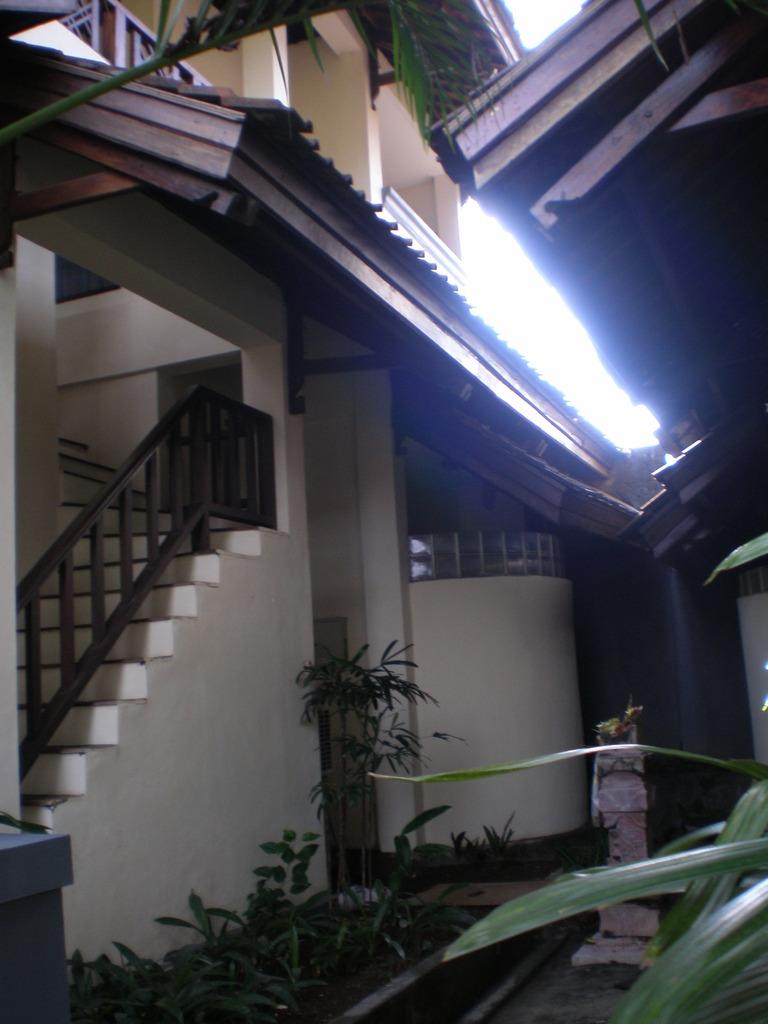What structure is located on the left side of the image? There is a building staircase on the left side of the image. What type of barrier can be seen in the image? There are fences in the image. What type of vegetation is present on the ground? Plants are present on the ground. Where is another plant located in the image? There is a plant on the right side of the image. What part of the building is visible in the image? There is a roof visible in the image. What is visible in the background of the image? The sky is visible in the background of the image. Can you tell me how many crows are sitting on the roof in the image? There are no crows present in the image; only the building staircase, fences, plants, and roof are visible. What type of sack is being used to carry the son in the image? There is no sack or son present in the image. 